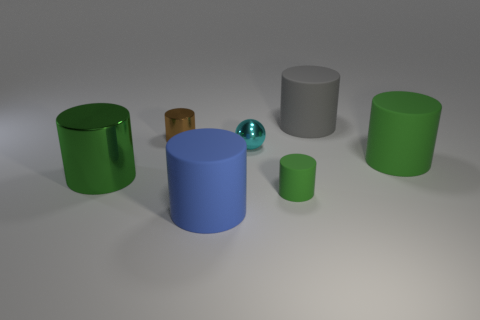How many cylinders are tiny objects or large blue matte objects?
Your answer should be very brief. 3. There is a small green thing; is it the same shape as the small metal thing behind the tiny sphere?
Provide a succinct answer. Yes. What number of matte cylinders have the same size as the blue thing?
Make the answer very short. 2. Does the matte object to the right of the big gray cylinder have the same shape as the object in front of the small green cylinder?
Ensure brevity in your answer.  Yes. There is a large metal object that is the same color as the tiny matte thing; what is its shape?
Your response must be concise. Cylinder. The large rubber cylinder in front of the green matte object that is to the right of the small green thing is what color?
Give a very brief answer. Blue. There is another metallic thing that is the same shape as the green metal object; what color is it?
Provide a succinct answer. Brown. What size is the blue rubber object that is the same shape as the tiny green object?
Your answer should be compact. Large. What material is the green cylinder that is to the left of the small rubber object?
Your response must be concise. Metal. Are there fewer matte cylinders right of the gray rubber cylinder than brown shiny cylinders?
Offer a very short reply. No. 